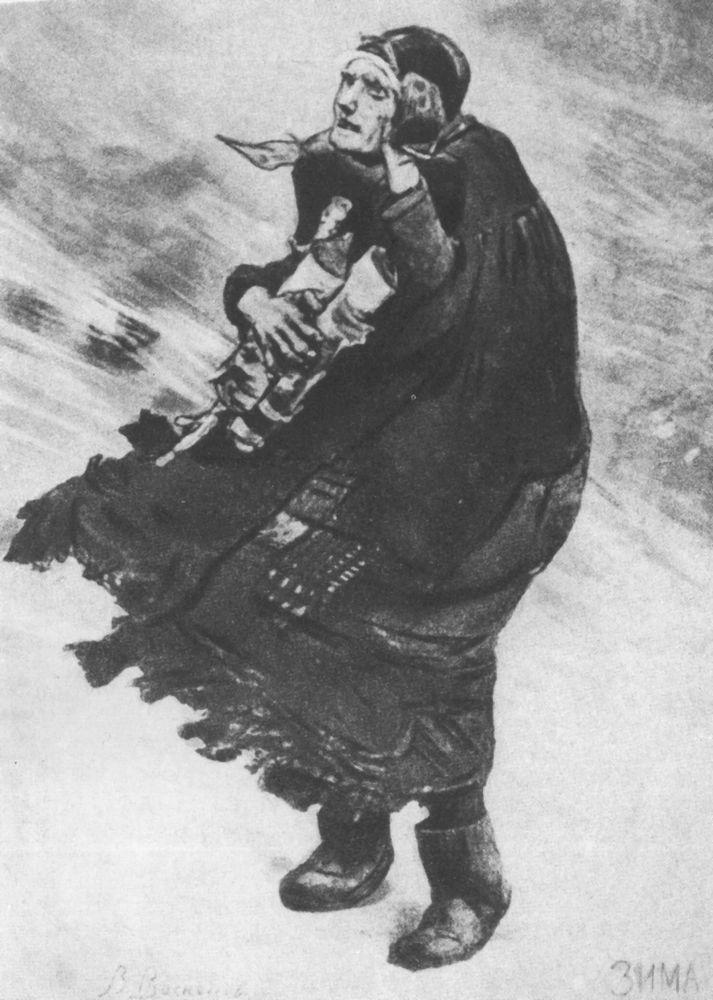What's happening in this impressive winter scene? In this impressive winter scene, we see a woman, clothed in a heavy dress and headscarf, courageously navigating through a fierce, snowy environment. She’s carrying a child on her back, wrapped warmly against the elements. The child holds a toy, their tiny hands clutching onto it for comfort. The swirling, blurred background suggests strong, cold winds. The determination visible on the woman's face and the protective way she holds the child reflect their struggle and resilience against nature’s harshness. It’s an evocative representation of survival and maternal care in the midst of adversity. Who is the artist that created this scene, and what might they have intended to convey with this artwork? This artwork is crafted by an artist skilled in evoking deep emotions through minimalistic yet powerful visuals. It seems the artist aimed to convey the themes of resilience, maternal protection, and the universal struggle against the elements. By using monochromatic tones, the artist strips the scene down to its emotional core, creating a timeless piece that underscores the strength and unwavering spirit of the human condition, particularly highlighting the bond between mother and child. Imagine the story behind this image. Who are these characters, and what led them to this moment? In a small, remote village during a particularly harsh winter, there lived a woman named Elara with her young son, Tomas. Elara, a widow, had faced many hardships but always remained steadfast for her son. On this day, they were forced to venture out into the merciless blizzard to seek medical help for Tomas, who had fallen ill. Elara wrapped him in layers of cloth and blankets, securing him on her back while tucking his favorite toy into his hands to comfort him. As they fought through the biting wind and swirling snow, her mind was solely focused on getting Tomas to safety. Every step was an act of courage and love, a testament to her indomitable spirit. This scene captures a fleeting moment in their arduous journey, a visual testament to the lengths a mother will go to protect her child. If this scene could suddenly come to life, what sounds or elements might we experience? If this scene could come to life, we would first hear the howling of the icy wind, cutting through the air with ferocious intensity. The sound of snow crunching underfoot would add a rhythmic, determined beat, as the woman trudges forward. Her labored breathing would signify the immense effort she's putting into each step. The rustle of fabric, from her dress and scarf, would rhythmically accompany her movements. Occasionally, the child might whimper softly, seeking reassurance. The overall soundscape would be dominated by the harsh, relentless winter elements, contrasted sharply with the softer, intimate sounds of this tender mother-child interaction. 